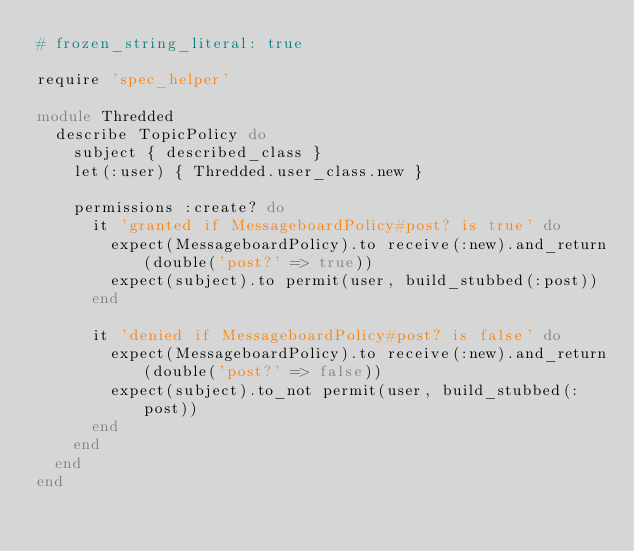<code> <loc_0><loc_0><loc_500><loc_500><_Ruby_># frozen_string_literal: true

require 'spec_helper'

module Thredded
  describe TopicPolicy do
    subject { described_class }
    let(:user) { Thredded.user_class.new }

    permissions :create? do
      it 'granted if MessageboardPolicy#post? is true' do
        expect(MessageboardPolicy).to receive(:new).and_return(double('post?' => true))
        expect(subject).to permit(user, build_stubbed(:post))
      end

      it 'denied if MessageboardPolicy#post? is false' do
        expect(MessageboardPolicy).to receive(:new).and_return(double('post?' => false))
        expect(subject).to_not permit(user, build_stubbed(:post))
      end
    end
  end
end
</code> 